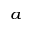Convert formula to latex. <formula><loc_0><loc_0><loc_500><loc_500>^ { a }</formula> 